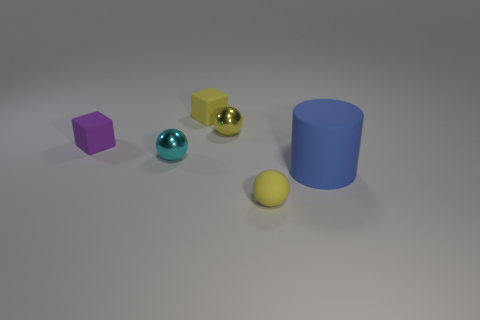Is the material of the small yellow object that is in front of the cyan ball the same as the cyan thing that is in front of the yellow cube?
Give a very brief answer. No. What shape is the tiny yellow matte thing to the left of the yellow object in front of the tiny shiny object behind the purple matte block?
Your response must be concise. Cube. How many tiny purple objects are the same material as the tiny purple cube?
Offer a terse response. 0. What number of yellow objects are in front of the cube that is right of the purple cube?
Offer a terse response. 2. Is the color of the tiny matte thing that is in front of the purple rubber cube the same as the matte block that is behind the small yellow metallic ball?
Ensure brevity in your answer.  Yes. The rubber thing that is both right of the yellow metal sphere and behind the rubber ball has what shape?
Keep it short and to the point. Cylinder. Is there a small yellow metallic object that has the same shape as the cyan metallic object?
Provide a short and direct response. Yes. There is a cyan object that is the same size as the yellow block; what is its shape?
Provide a short and direct response. Sphere. What is the material of the tiny cyan sphere?
Your answer should be very brief. Metal. There is a yellow rubber thing in front of the big matte object that is in front of the shiny thing to the right of the yellow cube; what is its size?
Offer a terse response. Small. 